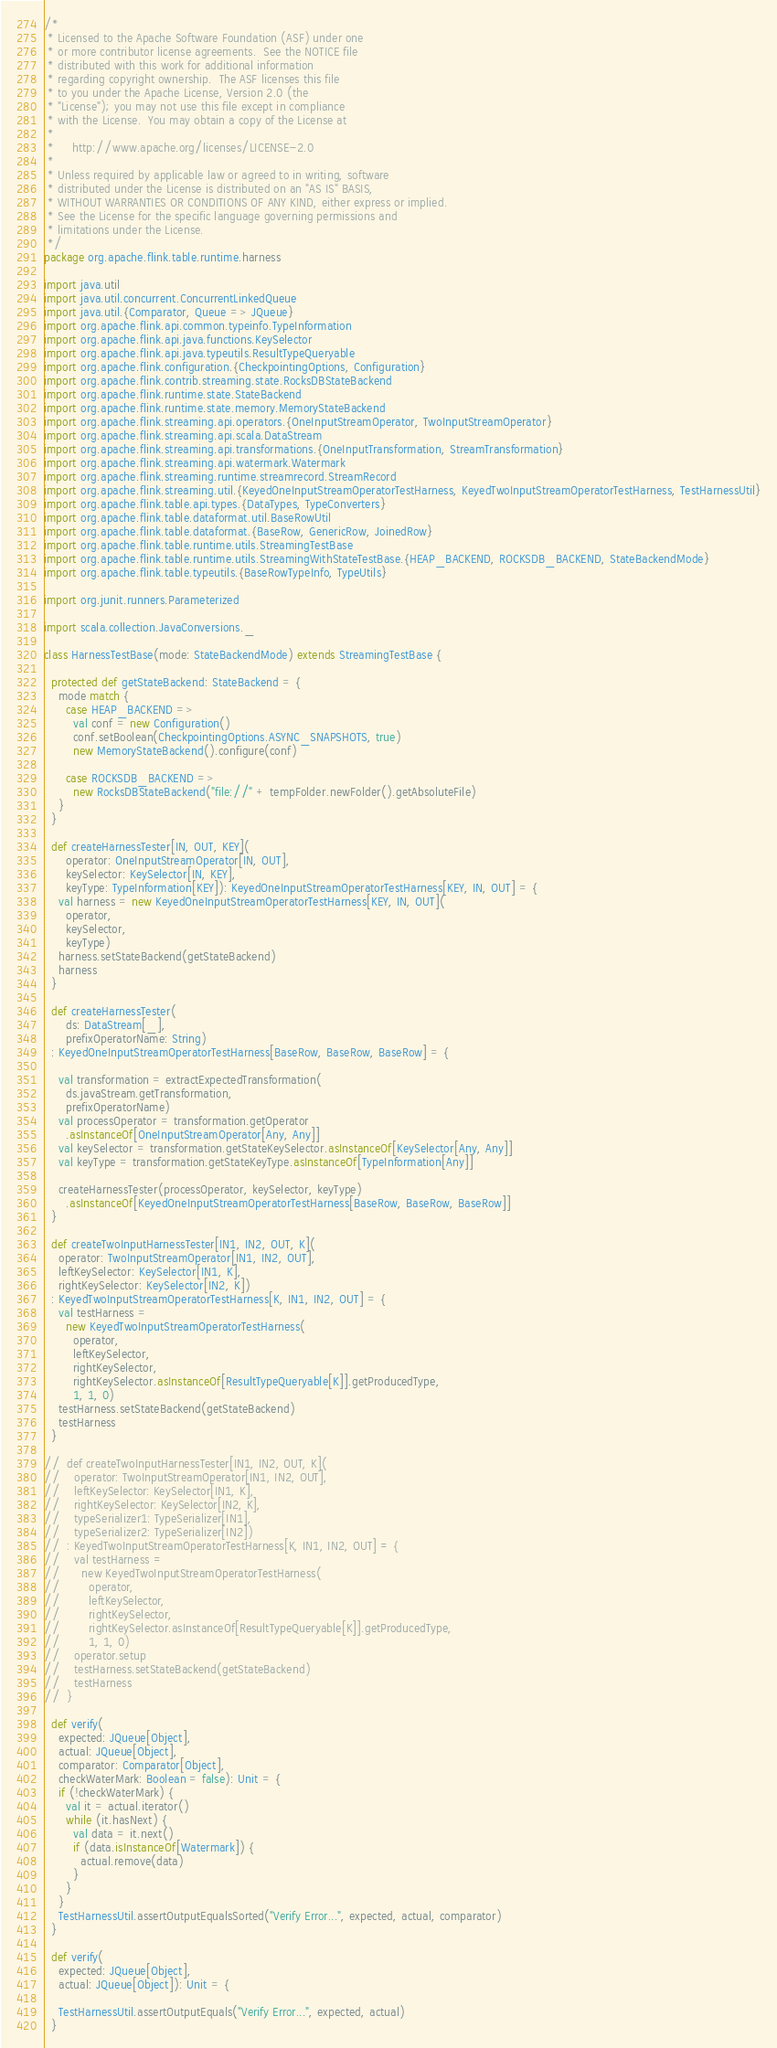Convert code to text. <code><loc_0><loc_0><loc_500><loc_500><_Scala_>/*
 * Licensed to the Apache Software Foundation (ASF) under one
 * or more contributor license agreements.  See the NOTICE file
 * distributed with this work for additional information
 * regarding copyright ownership.  The ASF licenses this file
 * to you under the Apache License, Version 2.0 (the
 * "License"); you may not use this file except in compliance
 * with the License.  You may obtain a copy of the License at
 *
 *     http://www.apache.org/licenses/LICENSE-2.0
 *
 * Unless required by applicable law or agreed to in writing, software
 * distributed under the License is distributed on an "AS IS" BASIS,
 * WITHOUT WARRANTIES OR CONDITIONS OF ANY KIND, either express or implied.
 * See the License for the specific language governing permissions and
 * limitations under the License.
 */
package org.apache.flink.table.runtime.harness

import java.util
import java.util.concurrent.ConcurrentLinkedQueue
import java.util.{Comparator, Queue => JQueue}
import org.apache.flink.api.common.typeinfo.TypeInformation
import org.apache.flink.api.java.functions.KeySelector
import org.apache.flink.api.java.typeutils.ResultTypeQueryable
import org.apache.flink.configuration.{CheckpointingOptions, Configuration}
import org.apache.flink.contrib.streaming.state.RocksDBStateBackend
import org.apache.flink.runtime.state.StateBackend
import org.apache.flink.runtime.state.memory.MemoryStateBackend
import org.apache.flink.streaming.api.operators.{OneInputStreamOperator, TwoInputStreamOperator}
import org.apache.flink.streaming.api.scala.DataStream
import org.apache.flink.streaming.api.transformations.{OneInputTransformation, StreamTransformation}
import org.apache.flink.streaming.api.watermark.Watermark
import org.apache.flink.streaming.runtime.streamrecord.StreamRecord
import org.apache.flink.streaming.util.{KeyedOneInputStreamOperatorTestHarness, KeyedTwoInputStreamOperatorTestHarness, TestHarnessUtil}
import org.apache.flink.table.api.types.{DataTypes, TypeConverters}
import org.apache.flink.table.dataformat.util.BaseRowUtil
import org.apache.flink.table.dataformat.{BaseRow, GenericRow, JoinedRow}
import org.apache.flink.table.runtime.utils.StreamingTestBase
import org.apache.flink.table.runtime.utils.StreamingWithStateTestBase.{HEAP_BACKEND, ROCKSDB_BACKEND, StateBackendMode}
import org.apache.flink.table.typeutils.{BaseRowTypeInfo, TypeUtils}

import org.junit.runners.Parameterized

import scala.collection.JavaConversions._

class HarnessTestBase(mode: StateBackendMode) extends StreamingTestBase {

  protected def getStateBackend: StateBackend = {
    mode match {
      case HEAP_BACKEND =>
        val conf = new Configuration()
        conf.setBoolean(CheckpointingOptions.ASYNC_SNAPSHOTS, true)
        new MemoryStateBackend().configure(conf)

      case ROCKSDB_BACKEND =>
        new RocksDBStateBackend("file://" + tempFolder.newFolder().getAbsoluteFile)
    }
  }

  def createHarnessTester[IN, OUT, KEY](
      operator: OneInputStreamOperator[IN, OUT],
      keySelector: KeySelector[IN, KEY],
      keyType: TypeInformation[KEY]): KeyedOneInputStreamOperatorTestHarness[KEY, IN, OUT] = {
    val harness = new KeyedOneInputStreamOperatorTestHarness[KEY, IN, OUT](
      operator,
      keySelector,
      keyType)
    harness.setStateBackend(getStateBackend)
    harness
  }

  def createHarnessTester(
      ds: DataStream[_],
      prefixOperatorName: String)
  : KeyedOneInputStreamOperatorTestHarness[BaseRow, BaseRow, BaseRow] = {

    val transformation = extractExpectedTransformation(
      ds.javaStream.getTransformation,
      prefixOperatorName)
    val processOperator = transformation.getOperator
      .asInstanceOf[OneInputStreamOperator[Any, Any]]
    val keySelector = transformation.getStateKeySelector.asInstanceOf[KeySelector[Any, Any]]
    val keyType = transformation.getStateKeyType.asInstanceOf[TypeInformation[Any]]

    createHarnessTester(processOperator, keySelector, keyType)
      .asInstanceOf[KeyedOneInputStreamOperatorTestHarness[BaseRow, BaseRow, BaseRow]]
  }

  def createTwoInputHarnessTester[IN1, IN2, OUT, K](
    operator: TwoInputStreamOperator[IN1, IN2, OUT],
    leftKeySelector: KeySelector[IN1, K],
    rightKeySelector: KeySelector[IN2, K])
  : KeyedTwoInputStreamOperatorTestHarness[K, IN1, IN2, OUT] = {
    val testHarness =
      new KeyedTwoInputStreamOperatorTestHarness(
        operator,
        leftKeySelector,
        rightKeySelector,
        rightKeySelector.asInstanceOf[ResultTypeQueryable[K]].getProducedType,
        1, 1, 0)
    testHarness.setStateBackend(getStateBackend)
    testHarness
  }

//  def createTwoInputHarnessTester[IN1, IN2, OUT, K](
//    operator: TwoInputStreamOperator[IN1, IN2, OUT],
//    leftKeySelector: KeySelector[IN1, K],
//    rightKeySelector: KeySelector[IN2, K],
//    typeSerializer1: TypeSerializer[IN1],
//    typeSerializer2: TypeSerializer[IN2])
//  : KeyedTwoInputStreamOperatorTestHarness[K, IN1, IN2, OUT] = {
//    val testHarness =
//      new KeyedTwoInputStreamOperatorTestHarness(
//        operator,
//        leftKeySelector,
//        rightKeySelector,
//        rightKeySelector.asInstanceOf[ResultTypeQueryable[K]].getProducedType,
//        1, 1, 0)
//    operator.setup
//    testHarness.setStateBackend(getStateBackend)
//    testHarness
//  }

  def verify(
    expected: JQueue[Object],
    actual: JQueue[Object],
    comparator: Comparator[Object],
    checkWaterMark: Boolean = false): Unit = {
    if (!checkWaterMark) {
      val it = actual.iterator()
      while (it.hasNext) {
        val data = it.next()
        if (data.isInstanceOf[Watermark]) {
          actual.remove(data)
        }
      }
    }
    TestHarnessUtil.assertOutputEqualsSorted("Verify Error...", expected, actual, comparator)
  }

  def verify(
    expected: JQueue[Object],
    actual: JQueue[Object]): Unit = {

    TestHarnessUtil.assertOutputEquals("Verify Error...", expected, actual)
  }
</code> 